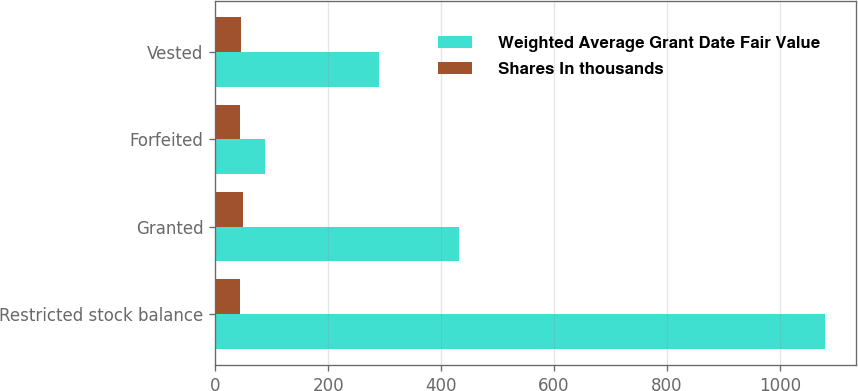Convert chart. <chart><loc_0><loc_0><loc_500><loc_500><stacked_bar_chart><ecel><fcel>Restricted stock balance<fcel>Granted<fcel>Forfeited<fcel>Vested<nl><fcel>Weighted Average Grant Date Fair Value<fcel>1080<fcel>432<fcel>88<fcel>289<nl><fcel>Shares In thousands<fcel>43.49<fcel>48.19<fcel>42.94<fcel>45.97<nl></chart> 